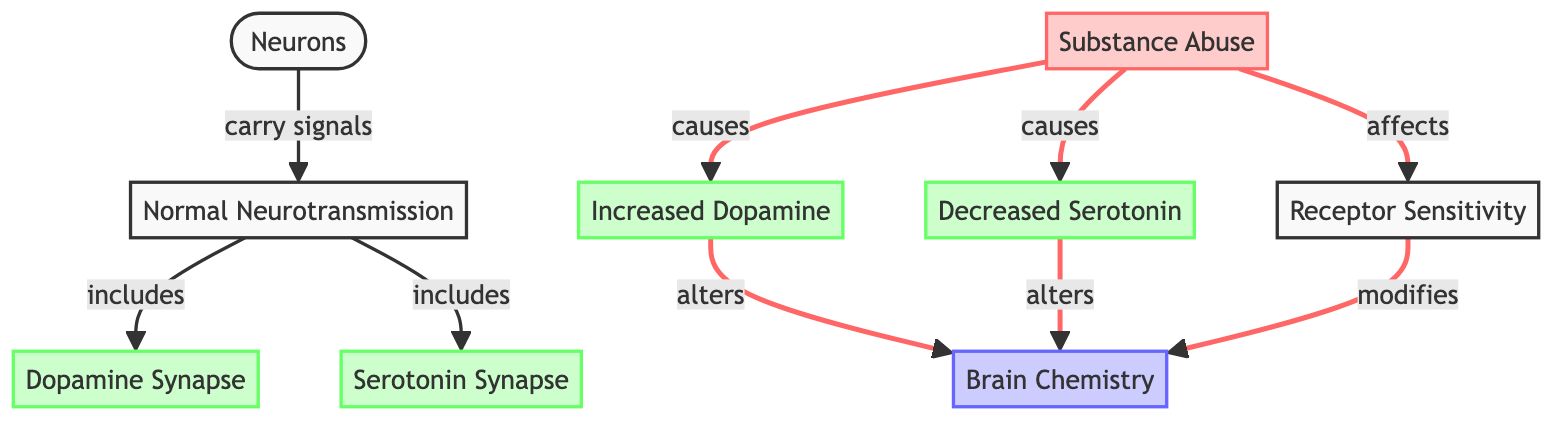What are the two neurotransmitter synapses included in normal neurotransmission? The diagram specifies two neurotransmitter synapses under the "Normal Neurotransmission" node: Dopamine Synapse and Serotonin Synapse.
Answer: Dopamine Synapse, Serotonin Synapse What effect does substance abuse have on dopamine levels? The diagram indicates that substance abuse causes an increase in dopamine levels, as shown by the arrow from "Substance Abuse" to "Increased Dopamine."
Answer: Increased Dopamine How many nodes are there in this diagram? Counting all the unique nodes, there are eight nodes in total: Neurons, Normal Neurotransmission, Dopamine Synapse, Serotonin Synapse, Substance Abuse, Increased Dopamine, Decreased Serotonin, and Brain Chemistry.
Answer: Eight What happens to serotonin levels as a result of substance abuse? "Substance Abuse" leads to "Decreased Serotonin," as depicted by the arrow in the diagram. This clearly shows that serotonin levels decrease due to substance abuse.
Answer: Decreased Serotonin Which node indicates an alteration in brain chemistry? Both "Increased Dopamine" and "Decreased Serotonin" indicate alterations in brain chemistry, both leading to the "Brain Chemistry" node, but the question specifically seeks one answer.
Answer: Brain Chemistry What overall effect does substance abuse have on receptor sensitivity? The diagram shows that substance abuse affects receptor sensitivity, which modifies brain chemistry, as indicated by the arrows in the diagram.
Answer: Affects Which neurotransmitter increases as a result of substance abuse, according to the diagram? The diagram explicitly states that substance abuse corresponds to "Increased Dopamine," as shown in the flow from "Substance Abuse."
Answer: Increased Dopamine How does decreased serotonin alter brain chemistry? The arrow indicating that "Decreased Serotonin" leads to "Brain Chemistry" illustrates that neurotransmission changes due to decreased serotonin levels.
Answer: Alters What is the relationship between neurons and normal neurotransmission? According to the diagram, neurons carry signals to "Normal Neurotransmission," which indicates a direct relationship of signal transmission.
Answer: Carry signals 